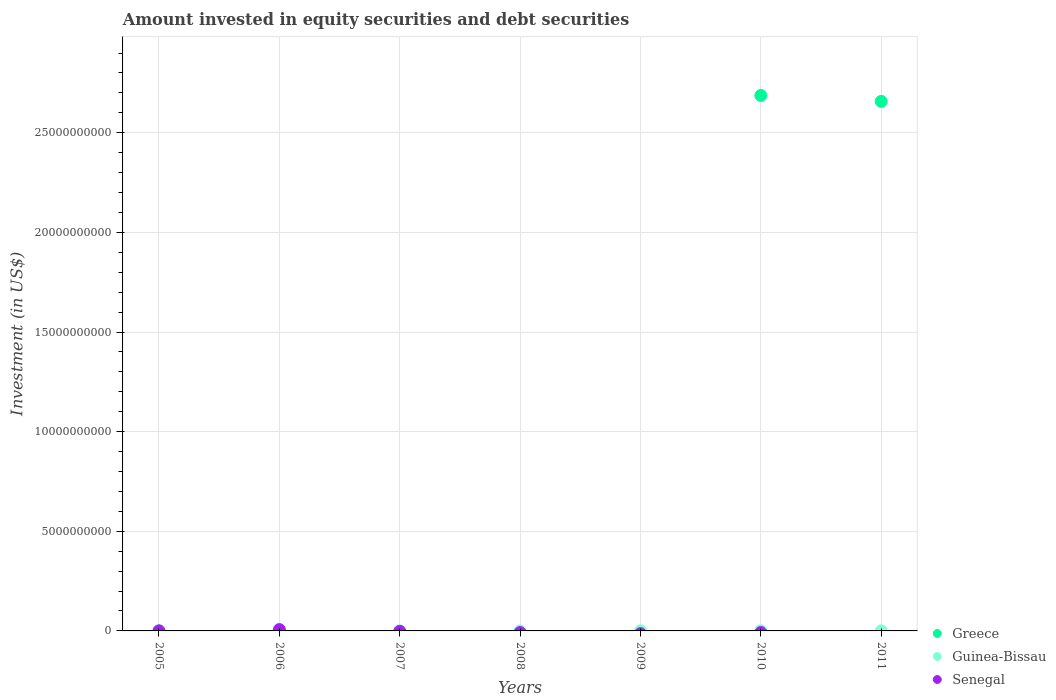What is the amount invested in equity securities and debt securities in Senegal in 2011?
Your answer should be very brief. 0. Across all years, what is the maximum amount invested in equity securities and debt securities in Senegal?
Keep it short and to the point. 6.70e+07. Across all years, what is the minimum amount invested in equity securities and debt securities in Guinea-Bissau?
Keep it short and to the point. 0. What is the total amount invested in equity securities and debt securities in Greece in the graph?
Offer a terse response. 5.34e+1. What is the difference between the amount invested in equity securities and debt securities in Guinea-Bissau in 2009 and the amount invested in equity securities and debt securities in Greece in 2008?
Ensure brevity in your answer.  5.75e+06. What is the average amount invested in equity securities and debt securities in Senegal per year?
Provide a succinct answer. 1.02e+07. In the year 2005, what is the difference between the amount invested in equity securities and debt securities in Senegal and amount invested in equity securities and debt securities in Guinea-Bissau?
Offer a terse response. -2.09e+05. In how many years, is the amount invested in equity securities and debt securities in Greece greater than 16000000000 US$?
Your answer should be very brief. 2. What is the ratio of the amount invested in equity securities and debt securities in Guinea-Bissau in 2005 to that in 2010?
Your response must be concise. 0.81. What is the difference between the highest and the second highest amount invested in equity securities and debt securities in Guinea-Bissau?
Your answer should be very brief. 1.40e+05. What is the difference between the highest and the lowest amount invested in equity securities and debt securities in Greece?
Your answer should be very brief. 2.69e+1. In how many years, is the amount invested in equity securities and debt securities in Senegal greater than the average amount invested in equity securities and debt securities in Senegal taken over all years?
Your response must be concise. 1. Is the amount invested in equity securities and debt securities in Guinea-Bissau strictly greater than the amount invested in equity securities and debt securities in Greece over the years?
Ensure brevity in your answer.  No. How many dotlines are there?
Offer a terse response. 3. How many years are there in the graph?
Your answer should be compact. 7. What is the difference between two consecutive major ticks on the Y-axis?
Your answer should be very brief. 5.00e+09. Does the graph contain any zero values?
Your answer should be very brief. Yes. How many legend labels are there?
Provide a succinct answer. 3. How are the legend labels stacked?
Provide a succinct answer. Vertical. What is the title of the graph?
Provide a succinct answer. Amount invested in equity securities and debt securities. What is the label or title of the Y-axis?
Give a very brief answer. Investment (in US$). What is the Investment (in US$) of Guinea-Bissau in 2005?
Give a very brief answer. 4.55e+06. What is the Investment (in US$) of Senegal in 2005?
Offer a terse response. 4.34e+06. What is the Investment (in US$) in Guinea-Bissau in 2006?
Keep it short and to the point. 0. What is the Investment (in US$) in Senegal in 2006?
Make the answer very short. 6.70e+07. What is the Investment (in US$) of Greece in 2007?
Provide a succinct answer. 0. What is the Investment (in US$) in Guinea-Bissau in 2007?
Give a very brief answer. 5.01e+06. What is the Investment (in US$) in Greece in 2008?
Provide a short and direct response. 0. What is the Investment (in US$) in Guinea-Bissau in 2008?
Make the answer very short. 0. What is the Investment (in US$) in Senegal in 2008?
Provide a short and direct response. 0. What is the Investment (in US$) of Guinea-Bissau in 2009?
Your response must be concise. 5.75e+06. What is the Investment (in US$) in Senegal in 2009?
Provide a short and direct response. 0. What is the Investment (in US$) of Greece in 2010?
Offer a very short reply. 2.69e+1. What is the Investment (in US$) in Guinea-Bissau in 2010?
Keep it short and to the point. 5.61e+06. What is the Investment (in US$) in Senegal in 2010?
Your answer should be compact. 0. What is the Investment (in US$) of Greece in 2011?
Make the answer very short. 2.66e+1. What is the Investment (in US$) of Guinea-Bissau in 2011?
Keep it short and to the point. 4.45e+06. What is the Investment (in US$) in Senegal in 2011?
Keep it short and to the point. 0. Across all years, what is the maximum Investment (in US$) of Greece?
Keep it short and to the point. 2.69e+1. Across all years, what is the maximum Investment (in US$) in Guinea-Bissau?
Provide a short and direct response. 5.75e+06. Across all years, what is the maximum Investment (in US$) in Senegal?
Your response must be concise. 6.70e+07. Across all years, what is the minimum Investment (in US$) in Greece?
Keep it short and to the point. 0. What is the total Investment (in US$) in Greece in the graph?
Provide a succinct answer. 5.34e+1. What is the total Investment (in US$) of Guinea-Bissau in the graph?
Your answer should be compact. 2.54e+07. What is the total Investment (in US$) of Senegal in the graph?
Provide a short and direct response. 7.13e+07. What is the difference between the Investment (in US$) in Senegal in 2005 and that in 2006?
Provide a succinct answer. -6.26e+07. What is the difference between the Investment (in US$) in Guinea-Bissau in 2005 and that in 2007?
Provide a succinct answer. -4.60e+05. What is the difference between the Investment (in US$) in Guinea-Bissau in 2005 and that in 2009?
Offer a very short reply. -1.20e+06. What is the difference between the Investment (in US$) in Guinea-Bissau in 2005 and that in 2010?
Give a very brief answer. -1.06e+06. What is the difference between the Investment (in US$) of Guinea-Bissau in 2005 and that in 2011?
Offer a very short reply. 1.04e+05. What is the difference between the Investment (in US$) in Guinea-Bissau in 2007 and that in 2009?
Provide a short and direct response. -7.40e+05. What is the difference between the Investment (in US$) of Guinea-Bissau in 2007 and that in 2010?
Provide a succinct answer. -6.00e+05. What is the difference between the Investment (in US$) in Guinea-Bissau in 2007 and that in 2011?
Keep it short and to the point. 5.64e+05. What is the difference between the Investment (in US$) of Guinea-Bissau in 2009 and that in 2010?
Ensure brevity in your answer.  1.40e+05. What is the difference between the Investment (in US$) of Guinea-Bissau in 2009 and that in 2011?
Make the answer very short. 1.30e+06. What is the difference between the Investment (in US$) of Greece in 2010 and that in 2011?
Ensure brevity in your answer.  2.97e+08. What is the difference between the Investment (in US$) of Guinea-Bissau in 2010 and that in 2011?
Provide a succinct answer. 1.16e+06. What is the difference between the Investment (in US$) in Guinea-Bissau in 2005 and the Investment (in US$) in Senegal in 2006?
Ensure brevity in your answer.  -6.24e+07. What is the difference between the Investment (in US$) in Greece in 2010 and the Investment (in US$) in Guinea-Bissau in 2011?
Ensure brevity in your answer.  2.69e+1. What is the average Investment (in US$) of Greece per year?
Your answer should be compact. 7.64e+09. What is the average Investment (in US$) in Guinea-Bissau per year?
Your answer should be compact. 3.62e+06. What is the average Investment (in US$) in Senegal per year?
Your answer should be very brief. 1.02e+07. In the year 2005, what is the difference between the Investment (in US$) of Guinea-Bissau and Investment (in US$) of Senegal?
Make the answer very short. 2.09e+05. In the year 2010, what is the difference between the Investment (in US$) of Greece and Investment (in US$) of Guinea-Bissau?
Your answer should be compact. 2.69e+1. In the year 2011, what is the difference between the Investment (in US$) of Greece and Investment (in US$) of Guinea-Bissau?
Provide a short and direct response. 2.66e+1. What is the ratio of the Investment (in US$) of Senegal in 2005 to that in 2006?
Your answer should be compact. 0.06. What is the ratio of the Investment (in US$) in Guinea-Bissau in 2005 to that in 2007?
Your response must be concise. 0.91. What is the ratio of the Investment (in US$) of Guinea-Bissau in 2005 to that in 2009?
Keep it short and to the point. 0.79. What is the ratio of the Investment (in US$) in Guinea-Bissau in 2005 to that in 2010?
Offer a very short reply. 0.81. What is the ratio of the Investment (in US$) in Guinea-Bissau in 2005 to that in 2011?
Your answer should be compact. 1.02. What is the ratio of the Investment (in US$) in Guinea-Bissau in 2007 to that in 2009?
Make the answer very short. 0.87. What is the ratio of the Investment (in US$) in Guinea-Bissau in 2007 to that in 2010?
Your response must be concise. 0.89. What is the ratio of the Investment (in US$) in Guinea-Bissau in 2007 to that in 2011?
Offer a very short reply. 1.13. What is the ratio of the Investment (in US$) of Guinea-Bissau in 2009 to that in 2010?
Ensure brevity in your answer.  1.02. What is the ratio of the Investment (in US$) in Guinea-Bissau in 2009 to that in 2011?
Offer a very short reply. 1.29. What is the ratio of the Investment (in US$) of Greece in 2010 to that in 2011?
Your answer should be very brief. 1.01. What is the ratio of the Investment (in US$) in Guinea-Bissau in 2010 to that in 2011?
Offer a very short reply. 1.26. What is the difference between the highest and the second highest Investment (in US$) in Guinea-Bissau?
Offer a terse response. 1.40e+05. What is the difference between the highest and the lowest Investment (in US$) in Greece?
Provide a succinct answer. 2.69e+1. What is the difference between the highest and the lowest Investment (in US$) in Guinea-Bissau?
Your answer should be compact. 5.75e+06. What is the difference between the highest and the lowest Investment (in US$) of Senegal?
Provide a succinct answer. 6.70e+07. 